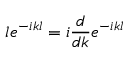Convert formula to latex. <formula><loc_0><loc_0><loc_500><loc_500>l e ^ { - i k l } = i \frac { d } { d k } e ^ { - i k l }</formula> 